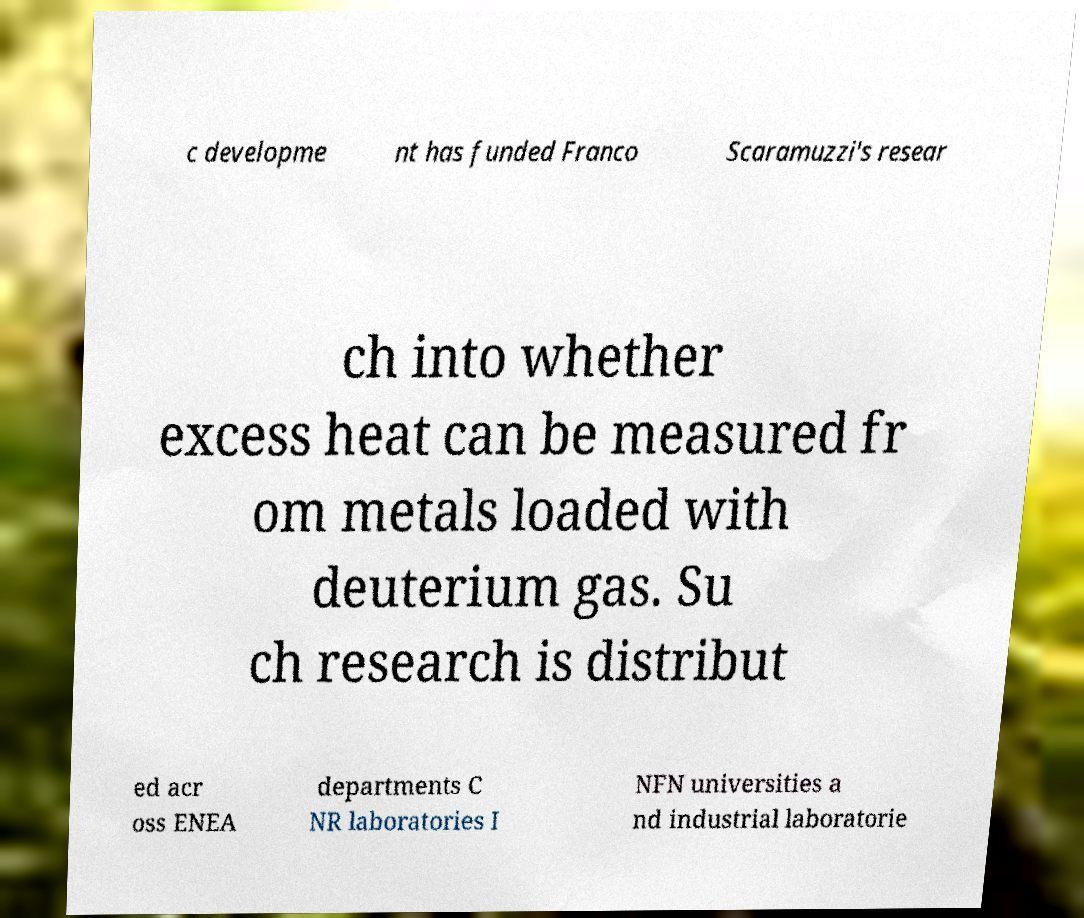Could you extract and type out the text from this image? c developme nt has funded Franco Scaramuzzi's resear ch into whether excess heat can be measured fr om metals loaded with deuterium gas. Su ch research is distribut ed acr oss ENEA departments C NR laboratories I NFN universities a nd industrial laboratorie 